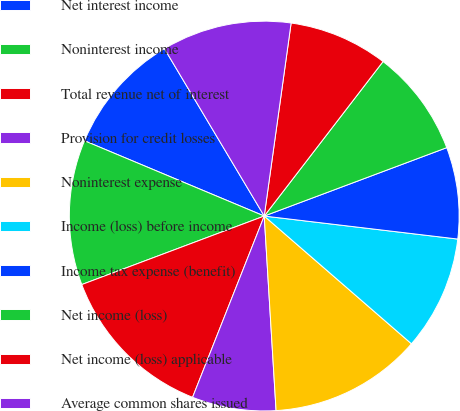Convert chart to OTSL. <chart><loc_0><loc_0><loc_500><loc_500><pie_chart><fcel>Net interest income<fcel>Noninterest income<fcel>Total revenue net of interest<fcel>Provision for credit losses<fcel>Noninterest expense<fcel>Income (loss) before income<fcel>Income tax expense (benefit)<fcel>Net income (loss)<fcel>Net income (loss) applicable<fcel>Average common shares issued<nl><fcel>10.13%<fcel>12.03%<fcel>13.29%<fcel>6.96%<fcel>12.66%<fcel>9.49%<fcel>7.59%<fcel>8.86%<fcel>8.23%<fcel>10.76%<nl></chart> 